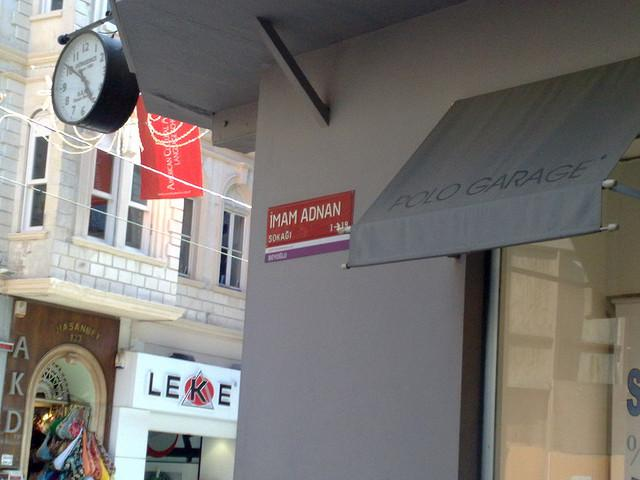What is the name of the Garage? polo 